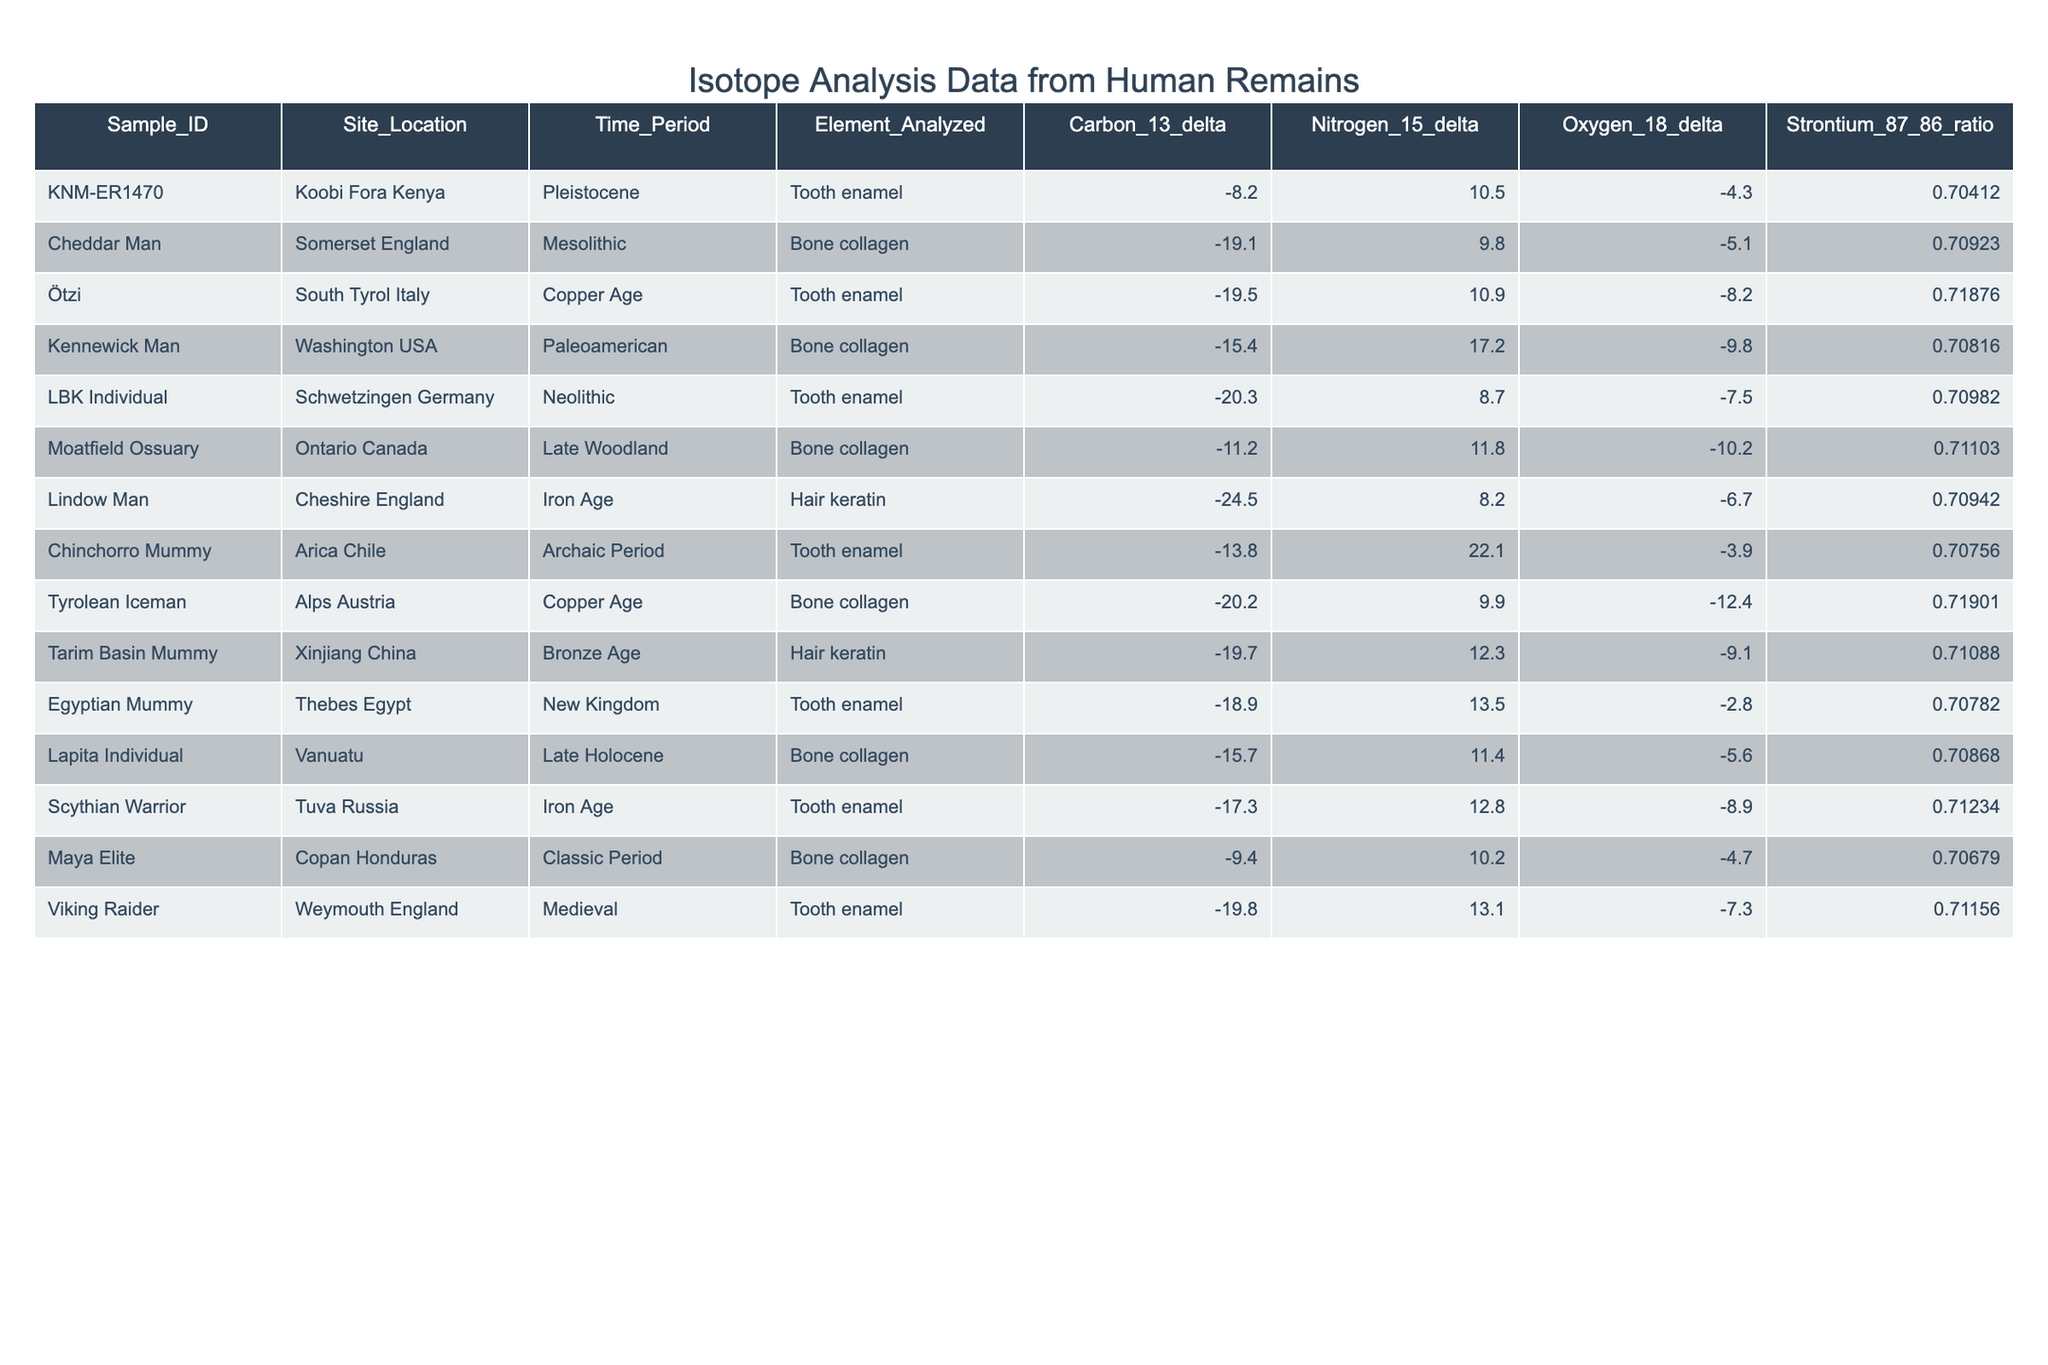What is the carbon-13 delta value for the Cheddar Man sample? By looking at the table under the column for Carbon-13 delta, I find that the value for the Cheddar Man sample (Sample_ID: Cheddar Man) is -19.1.
Answer: -19.1 What is the nitrogen-15 delta for the Scythian Warrior? The nitrogen-15 delta value for the Scythian Warrior, which is found in the row for that sample, is 12.8.
Answer: 12.8 Is the oxygen-18 delta for the Lapita Individual greater than -6? The oxygen-18 delta for the Lapita Individual is -5.6. Since -5.6 is greater than -6, the statement is true.
Answer: Yes Which sample has the highest strontium-87/86 ratio? By comparing the strontium-87/86 ratios in the table, I find that the Ötzi sample has the highest ratio at 0.71876.
Answer: Ötzi What is the average carbon-13 delta across all samples? First, I sum all carbon-13 deltas: (-8.2 - 19.1 - 19.5 - 15.4 - 20.3 - 11.2 - 24.5 - 13.8 - 20.2 - 19.7 - 18.9 - 15.7 - 17.3 - 9.4 - 19.8) = - 290.3. Then, divide by the number of samples, which is 15, yielding an average of -290.3 / 15 = -19.02.
Answer: -19.02 Does the Time Period column indicate that the Chinchorro Mummy sample dates back to the Iron Age? The Time Period listed for the Chinchorro Mummy is "Archaic Period," which is not the Iron Age. Therefore, it is false.
Answer: No What are the strontium-87/86 ratios of all samples from Europe and which one is the lowest? From the table, the European samples are Cheddar Man (0.70923), Ötzi (0.71876), LBK Individual (0.70982), Lindow Man (0.70942), Tyrolean Iceman (0.71901), and Viking Raider (0.71156). The lowest among these is the Cheddar Man at 0.70923.
Answer: Cheddar Man Which sample has both nitrogen-15 delta and carbon-13 delta values above 10? The only sample that meets this criterion is Chinchorro Mummy, which has a nitrogen-15 delta of 22.1 and a carbon-13 delta of -13.8 (while its carbon-13 is below 10, the nitrogen-15 is above, hence no). Therefore, there are no samples meeting both conditions.
Answer: None Which sample from the Bronze Age has the most negative carbon-13 delta? The Tarim Basin Mummy sample from the Bronze Age has a carbon-13 delta of -19.7. Examining other Bronze Age samples (but there are none), it confirms this is the lowest.
Answer: Tarim Basin Mummy 